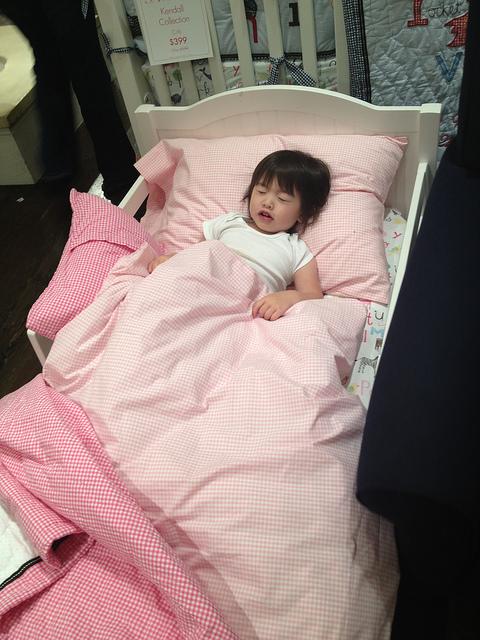What color is the girl's hair?
Give a very brief answer. Black. Is this bed big enough for the two tots?
Write a very short answer. No. What is the baby being fed?
Concise answer only. Nothing. Is this little girl wearing a pink shirt?
Give a very brief answer. No. Does the child look comfortable?
Give a very brief answer. Yes. What color are the sheets?
Short answer required. Pink. Is the child asleep?
Give a very brief answer. Yes. 